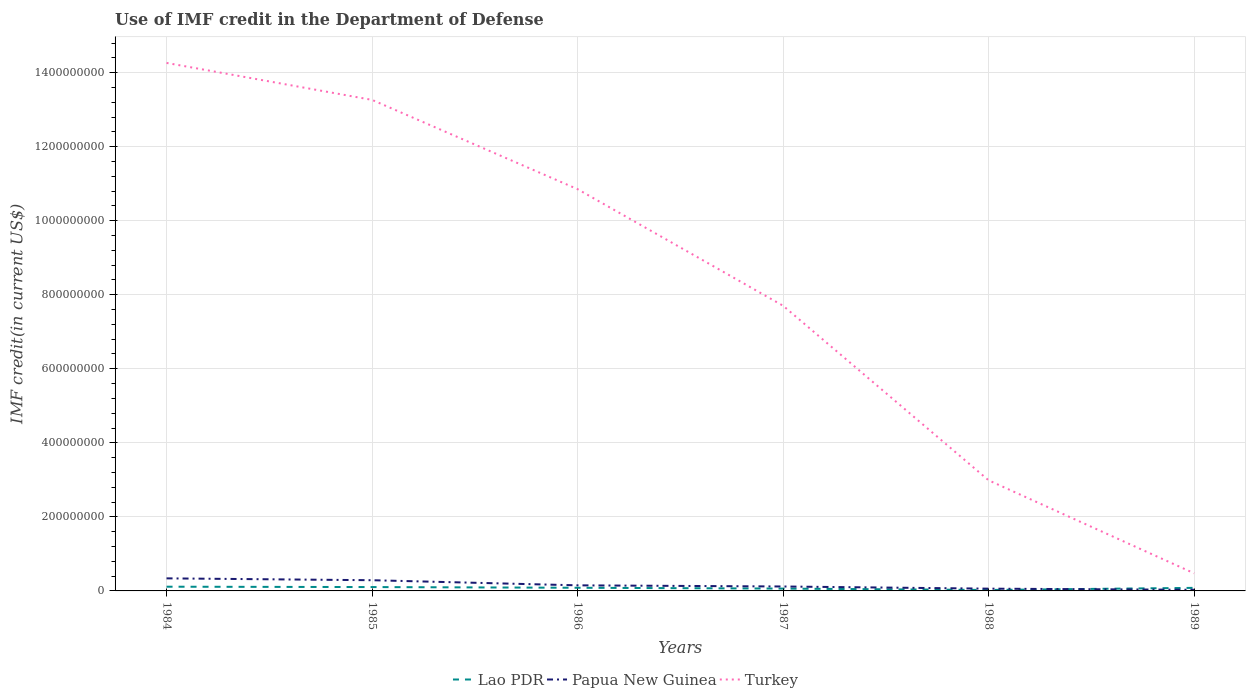How many different coloured lines are there?
Your answer should be compact. 3. Across all years, what is the maximum IMF credit in the Department of Defense in Turkey?
Give a very brief answer. 4.76e+07. What is the total IMF credit in the Department of Defense in Papua New Guinea in the graph?
Your answer should be compact. 2.28e+07. What is the difference between the highest and the second highest IMF credit in the Department of Defense in Papua New Guinea?
Your answer should be very brief. 3.09e+07. Are the values on the major ticks of Y-axis written in scientific E-notation?
Give a very brief answer. No. Does the graph contain any zero values?
Offer a terse response. No. How are the legend labels stacked?
Ensure brevity in your answer.  Horizontal. What is the title of the graph?
Ensure brevity in your answer.  Use of IMF credit in the Department of Defense. What is the label or title of the Y-axis?
Your response must be concise. IMF credit(in current US$). What is the IMF credit(in current US$) in Lao PDR in 1984?
Your answer should be very brief. 1.14e+07. What is the IMF credit(in current US$) of Papua New Guinea in 1984?
Your response must be concise. 3.39e+07. What is the IMF credit(in current US$) in Turkey in 1984?
Provide a short and direct response. 1.43e+09. What is the IMF credit(in current US$) of Lao PDR in 1985?
Your answer should be very brief. 1.04e+07. What is the IMF credit(in current US$) of Papua New Guinea in 1985?
Your answer should be compact. 2.89e+07. What is the IMF credit(in current US$) in Turkey in 1985?
Provide a short and direct response. 1.33e+09. What is the IMF credit(in current US$) in Lao PDR in 1986?
Give a very brief answer. 8.51e+06. What is the IMF credit(in current US$) in Papua New Guinea in 1986?
Ensure brevity in your answer.  1.51e+07. What is the IMF credit(in current US$) in Turkey in 1986?
Provide a succinct answer. 1.09e+09. What is the IMF credit(in current US$) in Lao PDR in 1987?
Provide a short and direct response. 6.28e+06. What is the IMF credit(in current US$) in Papua New Guinea in 1987?
Offer a very short reply. 1.20e+07. What is the IMF credit(in current US$) in Turkey in 1987?
Ensure brevity in your answer.  7.70e+08. What is the IMF credit(in current US$) of Lao PDR in 1988?
Keep it short and to the point. 2.55e+06. What is the IMF credit(in current US$) in Papua New Guinea in 1988?
Make the answer very short. 6.12e+06. What is the IMF credit(in current US$) of Turkey in 1988?
Your answer should be compact. 2.99e+08. What is the IMF credit(in current US$) of Lao PDR in 1989?
Provide a short and direct response. 8.28e+06. What is the IMF credit(in current US$) in Papua New Guinea in 1989?
Provide a succinct answer. 3.04e+06. What is the IMF credit(in current US$) in Turkey in 1989?
Provide a succinct answer. 4.76e+07. Across all years, what is the maximum IMF credit(in current US$) in Lao PDR?
Offer a very short reply. 1.14e+07. Across all years, what is the maximum IMF credit(in current US$) in Papua New Guinea?
Provide a succinct answer. 3.39e+07. Across all years, what is the maximum IMF credit(in current US$) in Turkey?
Offer a terse response. 1.43e+09. Across all years, what is the minimum IMF credit(in current US$) in Lao PDR?
Make the answer very short. 2.55e+06. Across all years, what is the minimum IMF credit(in current US$) of Papua New Guinea?
Ensure brevity in your answer.  3.04e+06. Across all years, what is the minimum IMF credit(in current US$) in Turkey?
Keep it short and to the point. 4.76e+07. What is the total IMF credit(in current US$) of Lao PDR in the graph?
Your answer should be compact. 4.74e+07. What is the total IMF credit(in current US$) in Papua New Guinea in the graph?
Ensure brevity in your answer.  9.91e+07. What is the total IMF credit(in current US$) of Turkey in the graph?
Your answer should be very brief. 4.95e+09. What is the difference between the IMF credit(in current US$) of Lao PDR in 1984 and that in 1985?
Offer a very short reply. 9.73e+05. What is the difference between the IMF credit(in current US$) in Papua New Guinea in 1984 and that in 1985?
Give a very brief answer. 5.02e+06. What is the difference between the IMF credit(in current US$) in Turkey in 1984 and that in 1985?
Provide a short and direct response. 9.98e+07. What is the difference between the IMF credit(in current US$) of Lao PDR in 1984 and that in 1986?
Ensure brevity in your answer.  2.88e+06. What is the difference between the IMF credit(in current US$) in Papua New Guinea in 1984 and that in 1986?
Your answer should be very brief. 1.88e+07. What is the difference between the IMF credit(in current US$) of Turkey in 1984 and that in 1986?
Offer a very short reply. 3.41e+08. What is the difference between the IMF credit(in current US$) in Lao PDR in 1984 and that in 1987?
Give a very brief answer. 5.12e+06. What is the difference between the IMF credit(in current US$) in Papua New Guinea in 1984 and that in 1987?
Keep it short and to the point. 2.20e+07. What is the difference between the IMF credit(in current US$) of Turkey in 1984 and that in 1987?
Make the answer very short. 6.56e+08. What is the difference between the IMF credit(in current US$) in Lao PDR in 1984 and that in 1988?
Ensure brevity in your answer.  8.84e+06. What is the difference between the IMF credit(in current US$) in Papua New Guinea in 1984 and that in 1988?
Provide a succinct answer. 2.78e+07. What is the difference between the IMF credit(in current US$) in Turkey in 1984 and that in 1988?
Provide a succinct answer. 1.13e+09. What is the difference between the IMF credit(in current US$) in Lao PDR in 1984 and that in 1989?
Ensure brevity in your answer.  3.11e+06. What is the difference between the IMF credit(in current US$) of Papua New Guinea in 1984 and that in 1989?
Your answer should be compact. 3.09e+07. What is the difference between the IMF credit(in current US$) of Turkey in 1984 and that in 1989?
Provide a short and direct response. 1.38e+09. What is the difference between the IMF credit(in current US$) in Lao PDR in 1985 and that in 1986?
Provide a succinct answer. 1.91e+06. What is the difference between the IMF credit(in current US$) in Papua New Guinea in 1985 and that in 1986?
Your answer should be compact. 1.38e+07. What is the difference between the IMF credit(in current US$) of Turkey in 1985 and that in 1986?
Keep it short and to the point. 2.41e+08. What is the difference between the IMF credit(in current US$) in Lao PDR in 1985 and that in 1987?
Make the answer very short. 4.14e+06. What is the difference between the IMF credit(in current US$) of Papua New Guinea in 1985 and that in 1987?
Offer a very short reply. 1.69e+07. What is the difference between the IMF credit(in current US$) of Turkey in 1985 and that in 1987?
Provide a short and direct response. 5.56e+08. What is the difference between the IMF credit(in current US$) in Lao PDR in 1985 and that in 1988?
Your answer should be very brief. 7.87e+06. What is the difference between the IMF credit(in current US$) of Papua New Guinea in 1985 and that in 1988?
Make the answer very short. 2.28e+07. What is the difference between the IMF credit(in current US$) in Turkey in 1985 and that in 1988?
Give a very brief answer. 1.03e+09. What is the difference between the IMF credit(in current US$) in Lao PDR in 1985 and that in 1989?
Provide a succinct answer. 2.14e+06. What is the difference between the IMF credit(in current US$) of Papua New Guinea in 1985 and that in 1989?
Your response must be concise. 2.59e+07. What is the difference between the IMF credit(in current US$) in Turkey in 1985 and that in 1989?
Provide a succinct answer. 1.28e+09. What is the difference between the IMF credit(in current US$) of Lao PDR in 1986 and that in 1987?
Offer a terse response. 2.23e+06. What is the difference between the IMF credit(in current US$) in Papua New Guinea in 1986 and that in 1987?
Ensure brevity in your answer.  3.11e+06. What is the difference between the IMF credit(in current US$) in Turkey in 1986 and that in 1987?
Make the answer very short. 3.15e+08. What is the difference between the IMF credit(in current US$) of Lao PDR in 1986 and that in 1988?
Offer a terse response. 5.96e+06. What is the difference between the IMF credit(in current US$) in Papua New Guinea in 1986 and that in 1988?
Give a very brief answer. 8.97e+06. What is the difference between the IMF credit(in current US$) in Turkey in 1986 and that in 1988?
Your answer should be compact. 7.86e+08. What is the difference between the IMF credit(in current US$) in Lao PDR in 1986 and that in 1989?
Your answer should be compact. 2.28e+05. What is the difference between the IMF credit(in current US$) in Papua New Guinea in 1986 and that in 1989?
Offer a terse response. 1.20e+07. What is the difference between the IMF credit(in current US$) of Turkey in 1986 and that in 1989?
Your answer should be very brief. 1.04e+09. What is the difference between the IMF credit(in current US$) of Lao PDR in 1987 and that in 1988?
Give a very brief answer. 3.73e+06. What is the difference between the IMF credit(in current US$) of Papua New Guinea in 1987 and that in 1988?
Provide a short and direct response. 5.86e+06. What is the difference between the IMF credit(in current US$) of Turkey in 1987 and that in 1988?
Give a very brief answer. 4.72e+08. What is the difference between the IMF credit(in current US$) in Lao PDR in 1987 and that in 1989?
Provide a short and direct response. -2.01e+06. What is the difference between the IMF credit(in current US$) in Papua New Guinea in 1987 and that in 1989?
Give a very brief answer. 8.94e+06. What is the difference between the IMF credit(in current US$) of Turkey in 1987 and that in 1989?
Your answer should be very brief. 7.23e+08. What is the difference between the IMF credit(in current US$) in Lao PDR in 1988 and that in 1989?
Your answer should be compact. -5.73e+06. What is the difference between the IMF credit(in current US$) in Papua New Guinea in 1988 and that in 1989?
Your response must be concise. 3.08e+06. What is the difference between the IMF credit(in current US$) of Turkey in 1988 and that in 1989?
Make the answer very short. 2.51e+08. What is the difference between the IMF credit(in current US$) of Lao PDR in 1984 and the IMF credit(in current US$) of Papua New Guinea in 1985?
Your answer should be very brief. -1.75e+07. What is the difference between the IMF credit(in current US$) in Lao PDR in 1984 and the IMF credit(in current US$) in Turkey in 1985?
Ensure brevity in your answer.  -1.31e+09. What is the difference between the IMF credit(in current US$) of Papua New Guinea in 1984 and the IMF credit(in current US$) of Turkey in 1985?
Make the answer very short. -1.29e+09. What is the difference between the IMF credit(in current US$) of Lao PDR in 1984 and the IMF credit(in current US$) of Papua New Guinea in 1986?
Your answer should be very brief. -3.69e+06. What is the difference between the IMF credit(in current US$) of Lao PDR in 1984 and the IMF credit(in current US$) of Turkey in 1986?
Your answer should be very brief. -1.07e+09. What is the difference between the IMF credit(in current US$) of Papua New Guinea in 1984 and the IMF credit(in current US$) of Turkey in 1986?
Offer a terse response. -1.05e+09. What is the difference between the IMF credit(in current US$) of Lao PDR in 1984 and the IMF credit(in current US$) of Papua New Guinea in 1987?
Ensure brevity in your answer.  -5.80e+05. What is the difference between the IMF credit(in current US$) of Lao PDR in 1984 and the IMF credit(in current US$) of Turkey in 1987?
Provide a short and direct response. -7.59e+08. What is the difference between the IMF credit(in current US$) of Papua New Guinea in 1984 and the IMF credit(in current US$) of Turkey in 1987?
Ensure brevity in your answer.  -7.36e+08. What is the difference between the IMF credit(in current US$) in Lao PDR in 1984 and the IMF credit(in current US$) in Papua New Guinea in 1988?
Your answer should be very brief. 5.28e+06. What is the difference between the IMF credit(in current US$) of Lao PDR in 1984 and the IMF credit(in current US$) of Turkey in 1988?
Ensure brevity in your answer.  -2.87e+08. What is the difference between the IMF credit(in current US$) of Papua New Guinea in 1984 and the IMF credit(in current US$) of Turkey in 1988?
Offer a very short reply. -2.65e+08. What is the difference between the IMF credit(in current US$) in Lao PDR in 1984 and the IMF credit(in current US$) in Papua New Guinea in 1989?
Give a very brief answer. 8.36e+06. What is the difference between the IMF credit(in current US$) of Lao PDR in 1984 and the IMF credit(in current US$) of Turkey in 1989?
Provide a short and direct response. -3.62e+07. What is the difference between the IMF credit(in current US$) in Papua New Guinea in 1984 and the IMF credit(in current US$) in Turkey in 1989?
Offer a terse response. -1.37e+07. What is the difference between the IMF credit(in current US$) of Lao PDR in 1985 and the IMF credit(in current US$) of Papua New Guinea in 1986?
Provide a short and direct response. -4.67e+06. What is the difference between the IMF credit(in current US$) of Lao PDR in 1985 and the IMF credit(in current US$) of Turkey in 1986?
Give a very brief answer. -1.07e+09. What is the difference between the IMF credit(in current US$) in Papua New Guinea in 1985 and the IMF credit(in current US$) in Turkey in 1986?
Make the answer very short. -1.06e+09. What is the difference between the IMF credit(in current US$) of Lao PDR in 1985 and the IMF credit(in current US$) of Papua New Guinea in 1987?
Give a very brief answer. -1.55e+06. What is the difference between the IMF credit(in current US$) in Lao PDR in 1985 and the IMF credit(in current US$) in Turkey in 1987?
Keep it short and to the point. -7.60e+08. What is the difference between the IMF credit(in current US$) of Papua New Guinea in 1985 and the IMF credit(in current US$) of Turkey in 1987?
Your answer should be very brief. -7.41e+08. What is the difference between the IMF credit(in current US$) in Lao PDR in 1985 and the IMF credit(in current US$) in Papua New Guinea in 1988?
Your response must be concise. 4.30e+06. What is the difference between the IMF credit(in current US$) in Lao PDR in 1985 and the IMF credit(in current US$) in Turkey in 1988?
Ensure brevity in your answer.  -2.88e+08. What is the difference between the IMF credit(in current US$) of Papua New Guinea in 1985 and the IMF credit(in current US$) of Turkey in 1988?
Keep it short and to the point. -2.70e+08. What is the difference between the IMF credit(in current US$) of Lao PDR in 1985 and the IMF credit(in current US$) of Papua New Guinea in 1989?
Provide a succinct answer. 7.38e+06. What is the difference between the IMF credit(in current US$) of Lao PDR in 1985 and the IMF credit(in current US$) of Turkey in 1989?
Provide a succinct answer. -3.72e+07. What is the difference between the IMF credit(in current US$) in Papua New Guinea in 1985 and the IMF credit(in current US$) in Turkey in 1989?
Make the answer very short. -1.87e+07. What is the difference between the IMF credit(in current US$) of Lao PDR in 1986 and the IMF credit(in current US$) of Papua New Guinea in 1987?
Your answer should be very brief. -3.46e+06. What is the difference between the IMF credit(in current US$) in Lao PDR in 1986 and the IMF credit(in current US$) in Turkey in 1987?
Your answer should be compact. -7.62e+08. What is the difference between the IMF credit(in current US$) in Papua New Guinea in 1986 and the IMF credit(in current US$) in Turkey in 1987?
Your response must be concise. -7.55e+08. What is the difference between the IMF credit(in current US$) of Lao PDR in 1986 and the IMF credit(in current US$) of Papua New Guinea in 1988?
Ensure brevity in your answer.  2.39e+06. What is the difference between the IMF credit(in current US$) of Lao PDR in 1986 and the IMF credit(in current US$) of Turkey in 1988?
Your answer should be compact. -2.90e+08. What is the difference between the IMF credit(in current US$) of Papua New Guinea in 1986 and the IMF credit(in current US$) of Turkey in 1988?
Offer a terse response. -2.84e+08. What is the difference between the IMF credit(in current US$) in Lao PDR in 1986 and the IMF credit(in current US$) in Papua New Guinea in 1989?
Make the answer very short. 5.47e+06. What is the difference between the IMF credit(in current US$) in Lao PDR in 1986 and the IMF credit(in current US$) in Turkey in 1989?
Make the answer very short. -3.91e+07. What is the difference between the IMF credit(in current US$) in Papua New Guinea in 1986 and the IMF credit(in current US$) in Turkey in 1989?
Make the answer very short. -3.25e+07. What is the difference between the IMF credit(in current US$) in Lao PDR in 1987 and the IMF credit(in current US$) in Papua New Guinea in 1988?
Ensure brevity in your answer.  1.58e+05. What is the difference between the IMF credit(in current US$) in Lao PDR in 1987 and the IMF credit(in current US$) in Turkey in 1988?
Give a very brief answer. -2.93e+08. What is the difference between the IMF credit(in current US$) of Papua New Guinea in 1987 and the IMF credit(in current US$) of Turkey in 1988?
Your response must be concise. -2.87e+08. What is the difference between the IMF credit(in current US$) of Lao PDR in 1987 and the IMF credit(in current US$) of Papua New Guinea in 1989?
Your response must be concise. 3.24e+06. What is the difference between the IMF credit(in current US$) of Lao PDR in 1987 and the IMF credit(in current US$) of Turkey in 1989?
Make the answer very short. -4.14e+07. What is the difference between the IMF credit(in current US$) in Papua New Guinea in 1987 and the IMF credit(in current US$) in Turkey in 1989?
Your answer should be very brief. -3.57e+07. What is the difference between the IMF credit(in current US$) in Lao PDR in 1988 and the IMF credit(in current US$) in Papua New Guinea in 1989?
Your answer should be very brief. -4.89e+05. What is the difference between the IMF credit(in current US$) of Lao PDR in 1988 and the IMF credit(in current US$) of Turkey in 1989?
Keep it short and to the point. -4.51e+07. What is the difference between the IMF credit(in current US$) in Papua New Guinea in 1988 and the IMF credit(in current US$) in Turkey in 1989?
Offer a very short reply. -4.15e+07. What is the average IMF credit(in current US$) in Lao PDR per year?
Make the answer very short. 7.91e+06. What is the average IMF credit(in current US$) of Papua New Guinea per year?
Keep it short and to the point. 1.65e+07. What is the average IMF credit(in current US$) of Turkey per year?
Make the answer very short. 8.26e+08. In the year 1984, what is the difference between the IMF credit(in current US$) of Lao PDR and IMF credit(in current US$) of Papua New Guinea?
Ensure brevity in your answer.  -2.25e+07. In the year 1984, what is the difference between the IMF credit(in current US$) in Lao PDR and IMF credit(in current US$) in Turkey?
Your answer should be compact. -1.41e+09. In the year 1984, what is the difference between the IMF credit(in current US$) in Papua New Guinea and IMF credit(in current US$) in Turkey?
Your answer should be compact. -1.39e+09. In the year 1985, what is the difference between the IMF credit(in current US$) of Lao PDR and IMF credit(in current US$) of Papua New Guinea?
Offer a terse response. -1.85e+07. In the year 1985, what is the difference between the IMF credit(in current US$) of Lao PDR and IMF credit(in current US$) of Turkey?
Your response must be concise. -1.32e+09. In the year 1985, what is the difference between the IMF credit(in current US$) in Papua New Guinea and IMF credit(in current US$) in Turkey?
Offer a terse response. -1.30e+09. In the year 1986, what is the difference between the IMF credit(in current US$) of Lao PDR and IMF credit(in current US$) of Papua New Guinea?
Ensure brevity in your answer.  -6.58e+06. In the year 1986, what is the difference between the IMF credit(in current US$) of Lao PDR and IMF credit(in current US$) of Turkey?
Offer a very short reply. -1.08e+09. In the year 1986, what is the difference between the IMF credit(in current US$) in Papua New Guinea and IMF credit(in current US$) in Turkey?
Your response must be concise. -1.07e+09. In the year 1987, what is the difference between the IMF credit(in current US$) in Lao PDR and IMF credit(in current US$) in Papua New Guinea?
Ensure brevity in your answer.  -5.70e+06. In the year 1987, what is the difference between the IMF credit(in current US$) of Lao PDR and IMF credit(in current US$) of Turkey?
Offer a very short reply. -7.64e+08. In the year 1987, what is the difference between the IMF credit(in current US$) in Papua New Guinea and IMF credit(in current US$) in Turkey?
Keep it short and to the point. -7.58e+08. In the year 1988, what is the difference between the IMF credit(in current US$) of Lao PDR and IMF credit(in current US$) of Papua New Guinea?
Ensure brevity in your answer.  -3.57e+06. In the year 1988, what is the difference between the IMF credit(in current US$) of Lao PDR and IMF credit(in current US$) of Turkey?
Provide a succinct answer. -2.96e+08. In the year 1988, what is the difference between the IMF credit(in current US$) in Papua New Guinea and IMF credit(in current US$) in Turkey?
Your answer should be very brief. -2.93e+08. In the year 1989, what is the difference between the IMF credit(in current US$) of Lao PDR and IMF credit(in current US$) of Papua New Guinea?
Offer a terse response. 5.24e+06. In the year 1989, what is the difference between the IMF credit(in current US$) of Lao PDR and IMF credit(in current US$) of Turkey?
Your answer should be compact. -3.94e+07. In the year 1989, what is the difference between the IMF credit(in current US$) of Papua New Guinea and IMF credit(in current US$) of Turkey?
Keep it short and to the point. -4.46e+07. What is the ratio of the IMF credit(in current US$) in Lao PDR in 1984 to that in 1985?
Your answer should be compact. 1.09. What is the ratio of the IMF credit(in current US$) of Papua New Guinea in 1984 to that in 1985?
Provide a succinct answer. 1.17. What is the ratio of the IMF credit(in current US$) in Turkey in 1984 to that in 1985?
Offer a very short reply. 1.08. What is the ratio of the IMF credit(in current US$) in Lao PDR in 1984 to that in 1986?
Give a very brief answer. 1.34. What is the ratio of the IMF credit(in current US$) in Papua New Guinea in 1984 to that in 1986?
Make the answer very short. 2.25. What is the ratio of the IMF credit(in current US$) of Turkey in 1984 to that in 1986?
Provide a short and direct response. 1.31. What is the ratio of the IMF credit(in current US$) in Lao PDR in 1984 to that in 1987?
Make the answer very short. 1.82. What is the ratio of the IMF credit(in current US$) of Papua New Guinea in 1984 to that in 1987?
Provide a succinct answer. 2.83. What is the ratio of the IMF credit(in current US$) of Turkey in 1984 to that in 1987?
Offer a very short reply. 1.85. What is the ratio of the IMF credit(in current US$) in Lao PDR in 1984 to that in 1988?
Offer a very short reply. 4.47. What is the ratio of the IMF credit(in current US$) in Papua New Guinea in 1984 to that in 1988?
Your answer should be compact. 5.54. What is the ratio of the IMF credit(in current US$) in Turkey in 1984 to that in 1988?
Your response must be concise. 4.77. What is the ratio of the IMF credit(in current US$) in Lao PDR in 1984 to that in 1989?
Provide a short and direct response. 1.38. What is the ratio of the IMF credit(in current US$) of Papua New Guinea in 1984 to that in 1989?
Your answer should be very brief. 11.16. What is the ratio of the IMF credit(in current US$) in Turkey in 1984 to that in 1989?
Make the answer very short. 29.94. What is the ratio of the IMF credit(in current US$) in Lao PDR in 1985 to that in 1986?
Your response must be concise. 1.22. What is the ratio of the IMF credit(in current US$) in Papua New Guinea in 1985 to that in 1986?
Provide a succinct answer. 1.92. What is the ratio of the IMF credit(in current US$) of Turkey in 1985 to that in 1986?
Make the answer very short. 1.22. What is the ratio of the IMF credit(in current US$) in Lao PDR in 1985 to that in 1987?
Ensure brevity in your answer.  1.66. What is the ratio of the IMF credit(in current US$) in Papua New Guinea in 1985 to that in 1987?
Your response must be concise. 2.41. What is the ratio of the IMF credit(in current US$) of Turkey in 1985 to that in 1987?
Offer a terse response. 1.72. What is the ratio of the IMF credit(in current US$) in Lao PDR in 1985 to that in 1988?
Keep it short and to the point. 4.09. What is the ratio of the IMF credit(in current US$) in Papua New Guinea in 1985 to that in 1988?
Your answer should be very brief. 4.72. What is the ratio of the IMF credit(in current US$) of Turkey in 1985 to that in 1988?
Make the answer very short. 4.44. What is the ratio of the IMF credit(in current US$) of Lao PDR in 1985 to that in 1989?
Keep it short and to the point. 1.26. What is the ratio of the IMF credit(in current US$) of Papua New Guinea in 1985 to that in 1989?
Provide a short and direct response. 9.51. What is the ratio of the IMF credit(in current US$) in Turkey in 1985 to that in 1989?
Offer a very short reply. 27.84. What is the ratio of the IMF credit(in current US$) of Lao PDR in 1986 to that in 1987?
Provide a succinct answer. 1.36. What is the ratio of the IMF credit(in current US$) of Papua New Guinea in 1986 to that in 1987?
Keep it short and to the point. 1.26. What is the ratio of the IMF credit(in current US$) of Turkey in 1986 to that in 1987?
Your answer should be compact. 1.41. What is the ratio of the IMF credit(in current US$) in Lao PDR in 1986 to that in 1988?
Make the answer very short. 3.34. What is the ratio of the IMF credit(in current US$) in Papua New Guinea in 1986 to that in 1988?
Offer a terse response. 2.47. What is the ratio of the IMF credit(in current US$) in Turkey in 1986 to that in 1988?
Offer a terse response. 3.63. What is the ratio of the IMF credit(in current US$) in Lao PDR in 1986 to that in 1989?
Your response must be concise. 1.03. What is the ratio of the IMF credit(in current US$) in Papua New Guinea in 1986 to that in 1989?
Keep it short and to the point. 4.96. What is the ratio of the IMF credit(in current US$) of Turkey in 1986 to that in 1989?
Provide a short and direct response. 22.78. What is the ratio of the IMF credit(in current US$) of Lao PDR in 1987 to that in 1988?
Offer a terse response. 2.46. What is the ratio of the IMF credit(in current US$) of Papua New Guinea in 1987 to that in 1988?
Give a very brief answer. 1.96. What is the ratio of the IMF credit(in current US$) in Turkey in 1987 to that in 1988?
Your response must be concise. 2.58. What is the ratio of the IMF credit(in current US$) in Lao PDR in 1987 to that in 1989?
Keep it short and to the point. 0.76. What is the ratio of the IMF credit(in current US$) in Papua New Guinea in 1987 to that in 1989?
Make the answer very short. 3.94. What is the ratio of the IMF credit(in current US$) of Turkey in 1987 to that in 1989?
Your response must be concise. 16.17. What is the ratio of the IMF credit(in current US$) in Lao PDR in 1988 to that in 1989?
Provide a succinct answer. 0.31. What is the ratio of the IMF credit(in current US$) of Papua New Guinea in 1988 to that in 1989?
Keep it short and to the point. 2.01. What is the ratio of the IMF credit(in current US$) of Turkey in 1988 to that in 1989?
Give a very brief answer. 6.27. What is the difference between the highest and the second highest IMF credit(in current US$) of Lao PDR?
Provide a short and direct response. 9.73e+05. What is the difference between the highest and the second highest IMF credit(in current US$) of Papua New Guinea?
Your response must be concise. 5.02e+06. What is the difference between the highest and the second highest IMF credit(in current US$) of Turkey?
Ensure brevity in your answer.  9.98e+07. What is the difference between the highest and the lowest IMF credit(in current US$) of Lao PDR?
Provide a short and direct response. 8.84e+06. What is the difference between the highest and the lowest IMF credit(in current US$) of Papua New Guinea?
Keep it short and to the point. 3.09e+07. What is the difference between the highest and the lowest IMF credit(in current US$) of Turkey?
Provide a succinct answer. 1.38e+09. 